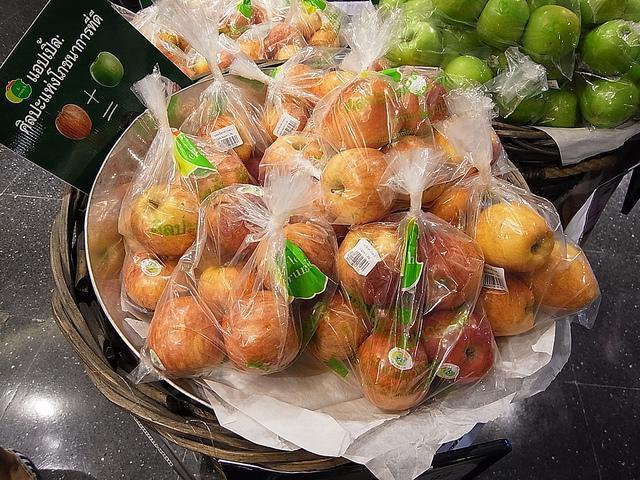How many apples are in the photo?
Give a very brief answer. 8. 